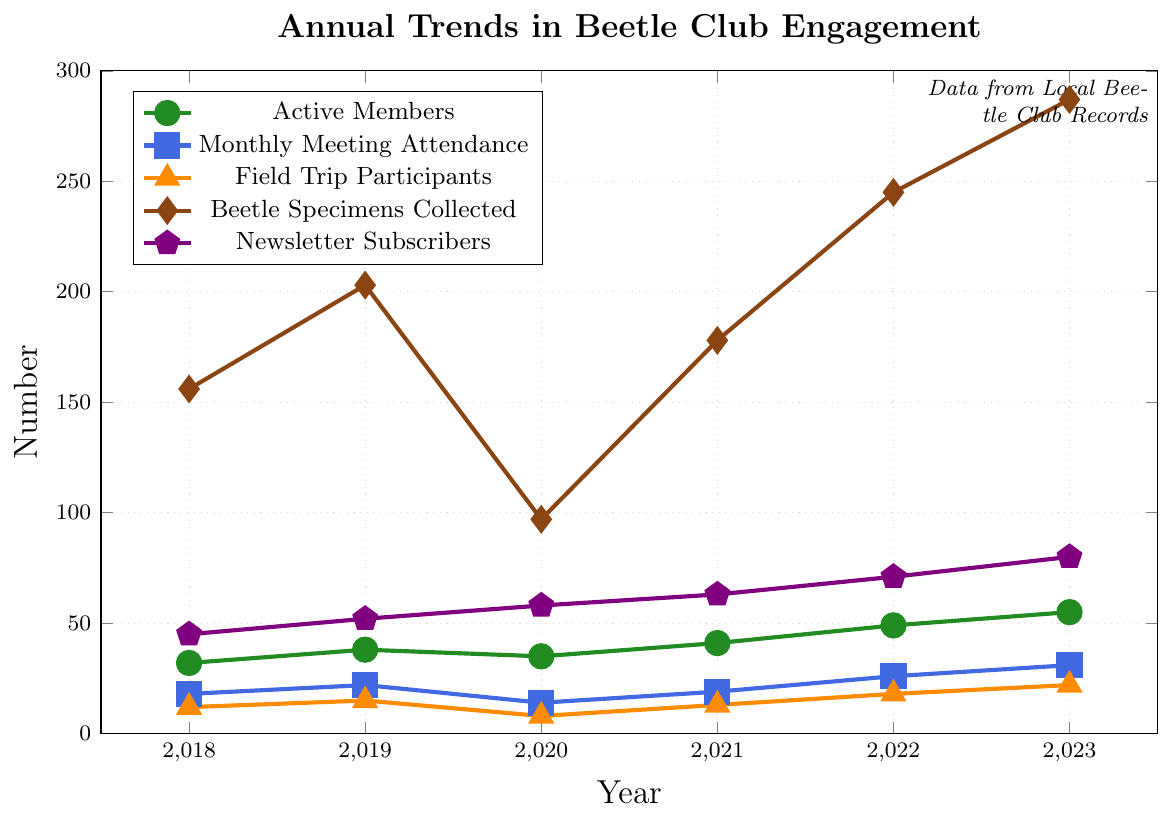What's the year with the highest number of active members? The data for active members is plotted with green circles on the figure. The highest point on this line indicates the year 2023 with 55 active members.
Answer: 2023 In which year did the beetle club collect the least number of specimens? The data for beetle specimens collected is represented using brown diamonds. The lowest point in this series is in the year 2020 with 97 specimens collected.
Answer: 2020 How did the number of monthly meeting attendees change between 2018 and 2019? Looking at the blue squares which represent monthly meeting attendance, the value increases from 18 in 2018 to 22 in 2019. The difference is 22 - 18.
Answer: Increased by 4 Which year saw the lowest number of field trip participants, and what was the number? The orange triangles represent field trip participants. The lowest point on this line is in the year 2020 with 8 participants.
Answer: 2020, 8 How do the trends in newsletter subscribers and active members compare from 2020 to 2023? Both active members (green circles) and newsletter subscribers (purple pentagons) increased from 2020 to 2023. Active members went from 35 to 55, while newsletter subscribers went from 58 to 80, showing a consistent upward trend.
Answer: Both showed consistent increase What was the total number of active members from 2018 to 2023? Sum the active members for each year: 32+38+35+41+49+55. The calculation is 250.
Answer: 250 By how much did the beetle specimens collected increase from 2020 to 2023? The beetle specimens collected in 2020 were 97 and in 2023 were 287. The increase is 287 - 97.
Answer: Increased by 190 Which category experienced the largest drop in value from one year to the next? Looking at all the lines on the figure, the biggest drop is in beetle specimens collected from 2019 (203) to 2020 (97), a decrease by 203 - 97.
Answer: Beetle specimens collected, 106 In which year did newsletter subscribers surpass 70? The purple pentagons represent newsletter subscribers. The number surpasses 70 in the year 2022 with 71 subscribers.
Answer: 2022 Which year had the highest attendance of monthly meetings, and how many attendees were recorded? The blue squares represent monthly meeting attendance. The highest point is in 2023 with 31 attendees.
Answer: 2023, 31 